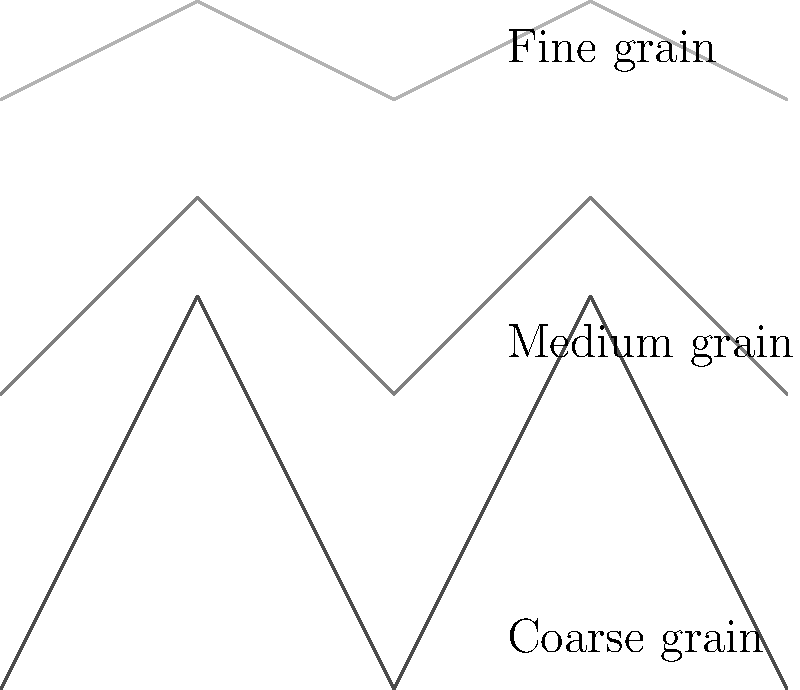In classic black and white films, which type of film grain pattern is typically associated with higher film speed and lower light conditions? To answer this question, let's consider the relationship between film grain, film speed, and light conditions in classic black and white photography:

1. Film grain is the random texture of processed photographic film due to the presence of small particles of metallic silver.

2. Film speed (ISO) refers to the light sensitivity of the film. Higher ISO numbers indicate greater sensitivity to light.

3. In low light conditions, photographers often use higher speed film to capture images without underexposure.

4. Higher speed films have larger silver halide crystals, which results in more noticeable grain patterns.

5. The grain pattern becomes more pronounced as the film speed increases:
   - Low speed films (ISO 100 or lower) typically have fine, barely noticeable grain.
   - Medium speed films (ISO 200-400) have a more visible, medium grain pattern.
   - High speed films (ISO 800 and above) exhibit coarse, clearly visible grain patterns.

6. In the diagram, we can see representations of fine, medium, and coarse grain patterns.

7. The coarse grain pattern, shown at the bottom of the diagram, is characteristic of high-speed films used in low light conditions.

Therefore, the coarse grain pattern is typically associated with higher film speed and lower light conditions in classic black and white films.
Answer: Coarse grain 